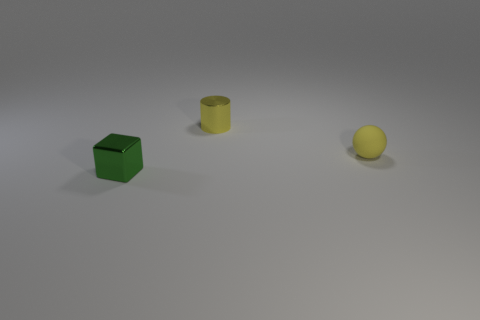Is there any other thing that is the same material as the tiny yellow sphere?
Ensure brevity in your answer.  No. The small metal object that is behind the yellow object in front of the small yellow metallic object is what color?
Offer a very short reply. Yellow. Is the number of small cylinders that are in front of the yellow metal cylinder the same as the number of purple matte blocks?
Keep it short and to the point. Yes. Are there any yellow cylinders that have the same size as the green metallic thing?
Give a very brief answer. Yes. Are there an equal number of small rubber things that are left of the yellow matte object and tiny metallic objects that are on the right side of the cube?
Provide a short and direct response. No. There is a tiny thing that is the same color as the metallic cylinder; what shape is it?
Give a very brief answer. Sphere. There is a yellow thing that is left of the tiny matte ball; what is it made of?
Provide a short and direct response. Metal. Is the number of tiny matte things that are to the right of the tiny yellow metallic object greater than the number of red spheres?
Ensure brevity in your answer.  Yes. What is the size of the green cube that is the same material as the small yellow cylinder?
Offer a very short reply. Small. There is a cube; are there any small yellow objects on the right side of it?
Provide a short and direct response. Yes. 